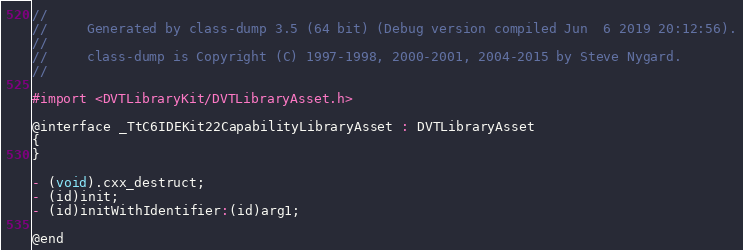Convert code to text. <code><loc_0><loc_0><loc_500><loc_500><_C_>//
//     Generated by class-dump 3.5 (64 bit) (Debug version compiled Jun  6 2019 20:12:56).
//
//     class-dump is Copyright (C) 1997-1998, 2000-2001, 2004-2015 by Steve Nygard.
//

#import <DVTLibraryKit/DVTLibraryAsset.h>

@interface _TtC6IDEKit22CapabilityLibraryAsset : DVTLibraryAsset
{
}

- (void).cxx_destruct;
- (id)init;
- (id)initWithIdentifier:(id)arg1;

@end

</code> 